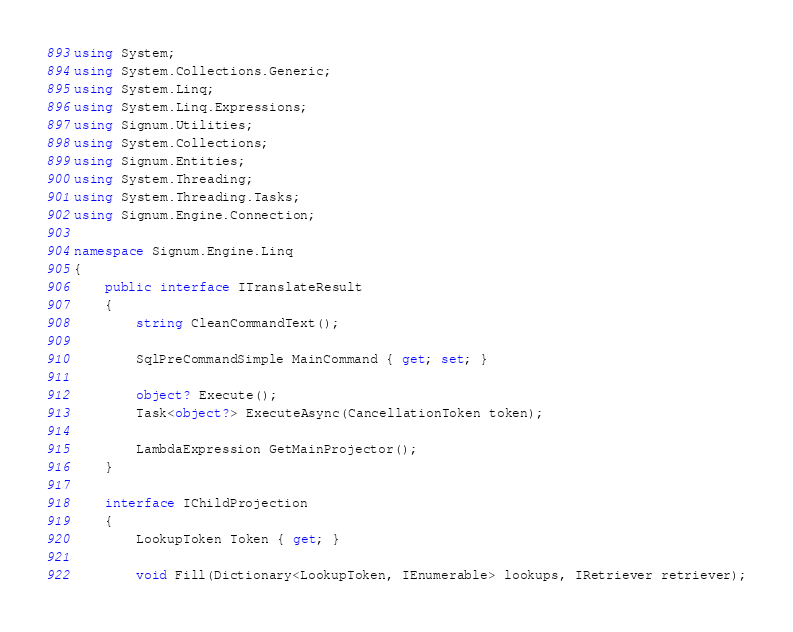<code> <loc_0><loc_0><loc_500><loc_500><_C#_>using System;
using System.Collections.Generic;
using System.Linq;
using System.Linq.Expressions;
using Signum.Utilities;
using System.Collections;
using Signum.Entities;
using System.Threading;
using System.Threading.Tasks;
using Signum.Engine.Connection;

namespace Signum.Engine.Linq
{
    public interface ITranslateResult
    {
        string CleanCommandText();

        SqlPreCommandSimple MainCommand { get; set; }

        object? Execute();
        Task<object?> ExecuteAsync(CancellationToken token);

        LambdaExpression GetMainProjector();
    }

    interface IChildProjection
    {
        LookupToken Token { get; }

        void Fill(Dictionary<LookupToken, IEnumerable> lookups, IRetriever retriever);</code> 